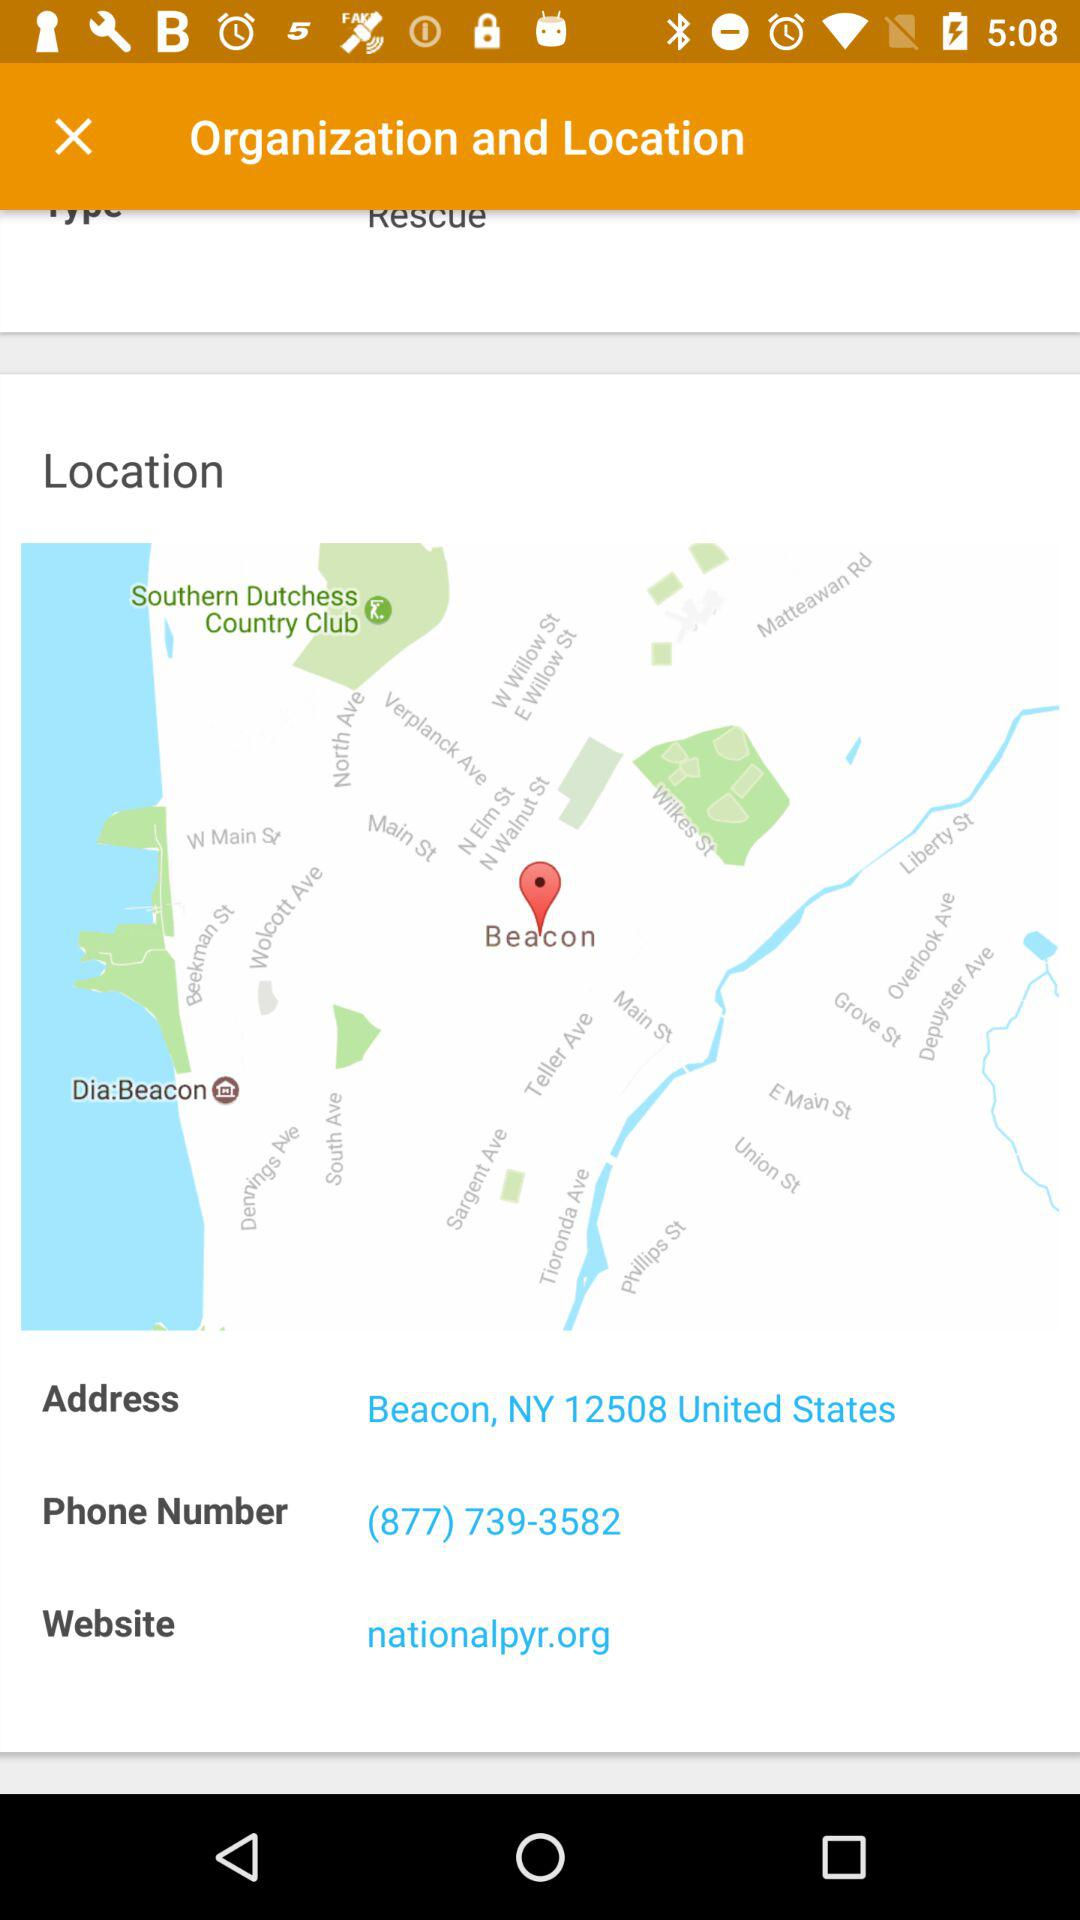What is the given phone number? The given phone number is (877) 739-3582. 